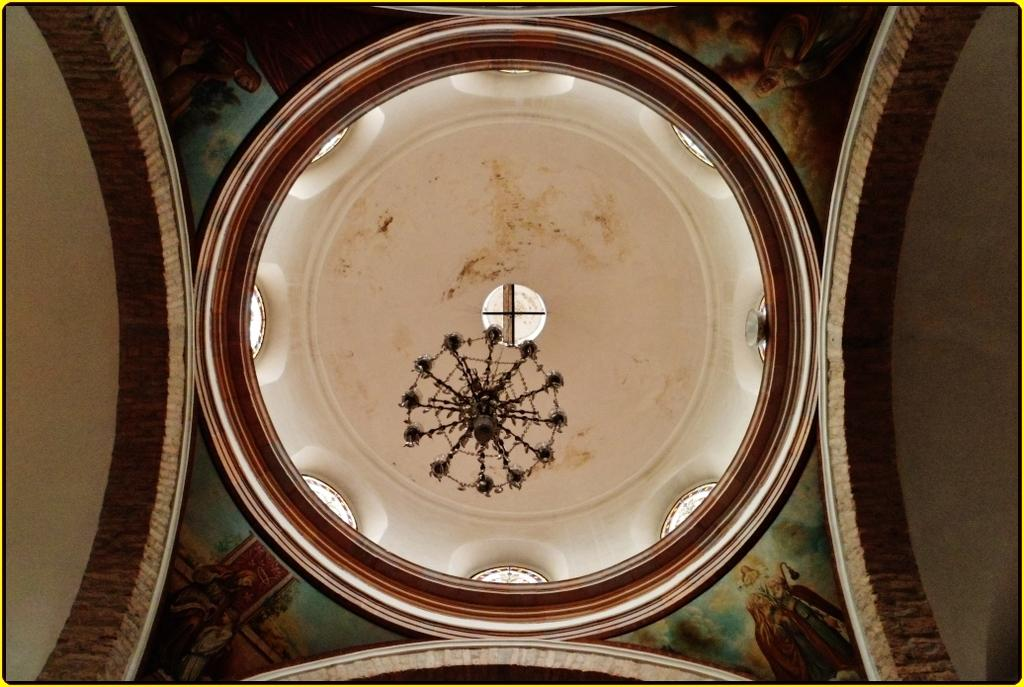What is present on top of the structure in the image? There is a roof in the image. What can be seen on the roof? There are paintings on the roof. What type of engine is powering the songs in the image? There are no songs or engines present in the image; it only features a roof with paintings. 